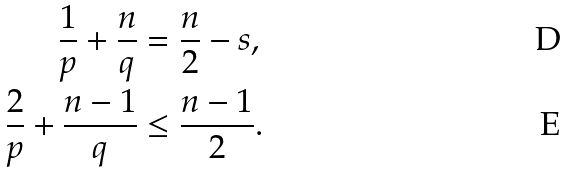<formula> <loc_0><loc_0><loc_500><loc_500>\frac { 1 } { p } + \frac { n } { q } & = \frac { n } { 2 } - s , \\ \frac { 2 } { p } + \frac { n - 1 } { q } & \leq \frac { n - 1 } { 2 } .</formula> 